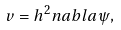<formula> <loc_0><loc_0><loc_500><loc_500>v = h ^ { 2 } n a b l a \psi ,</formula> 